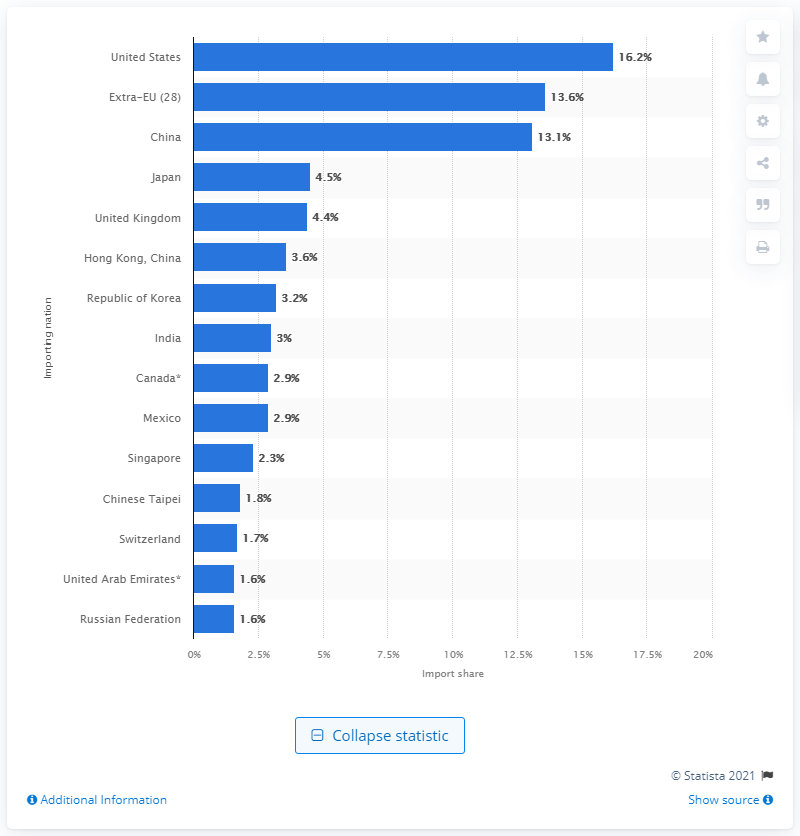Draw attention to some important aspects in this diagram. In 2019, the import share of the United States was 16.2%. 